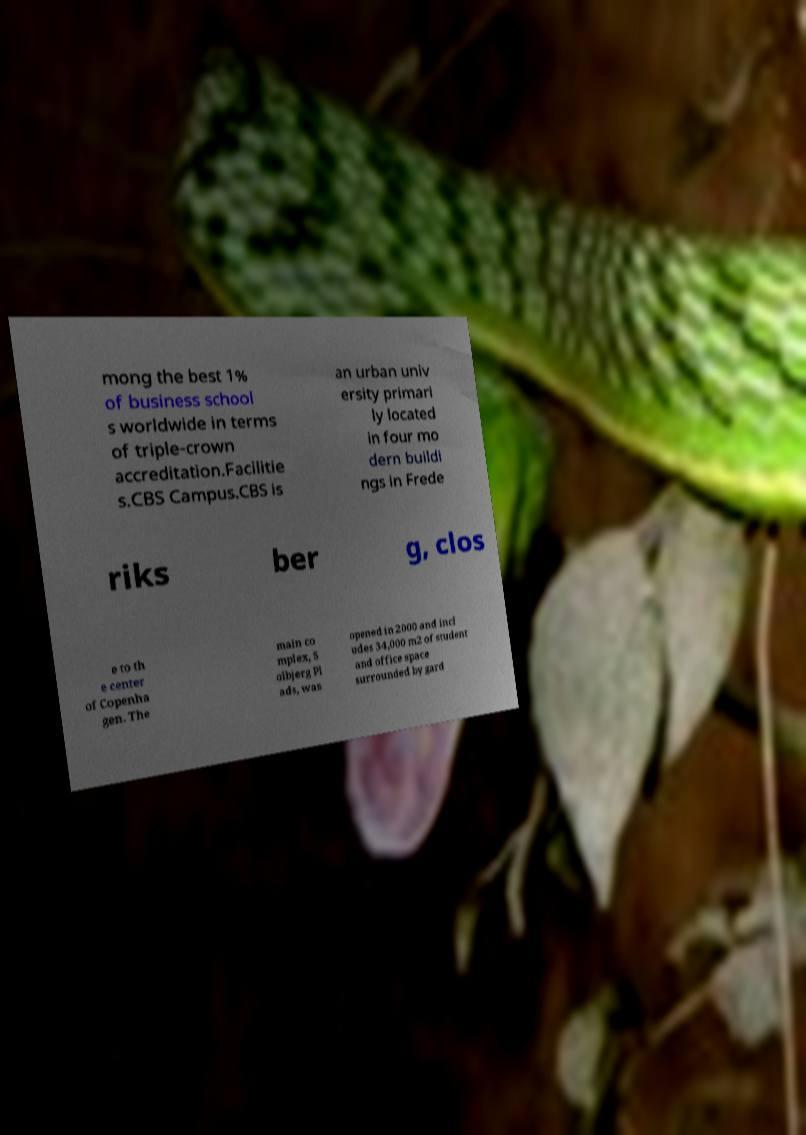For documentation purposes, I need the text within this image transcribed. Could you provide that? mong the best 1% of business school s worldwide in terms of triple-crown accreditation.Facilitie s.CBS Campus.CBS is an urban univ ersity primari ly located in four mo dern buildi ngs in Frede riks ber g, clos e to th e center of Copenha gen. The main co mplex, S olbjerg Pl ads, was opened in 2000 and incl udes 34,000 m2 of student and office space surrounded by gard 